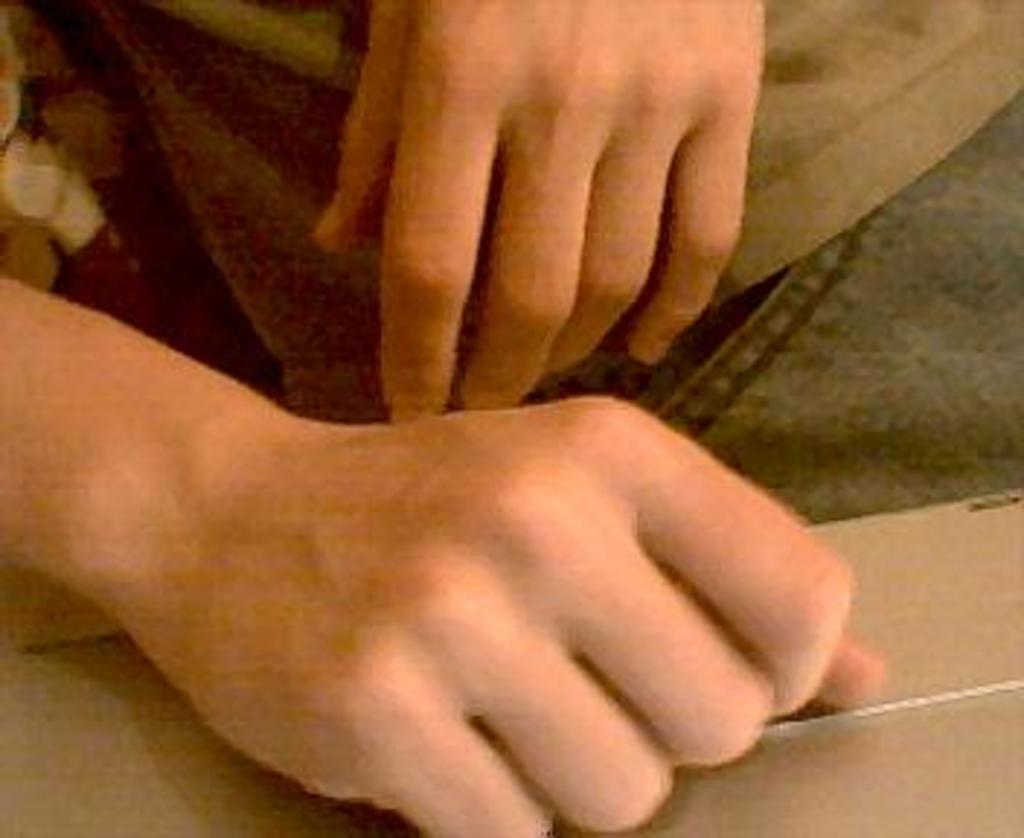In one or two sentences, can you explain what this image depicts? In the image we can see two hands. 